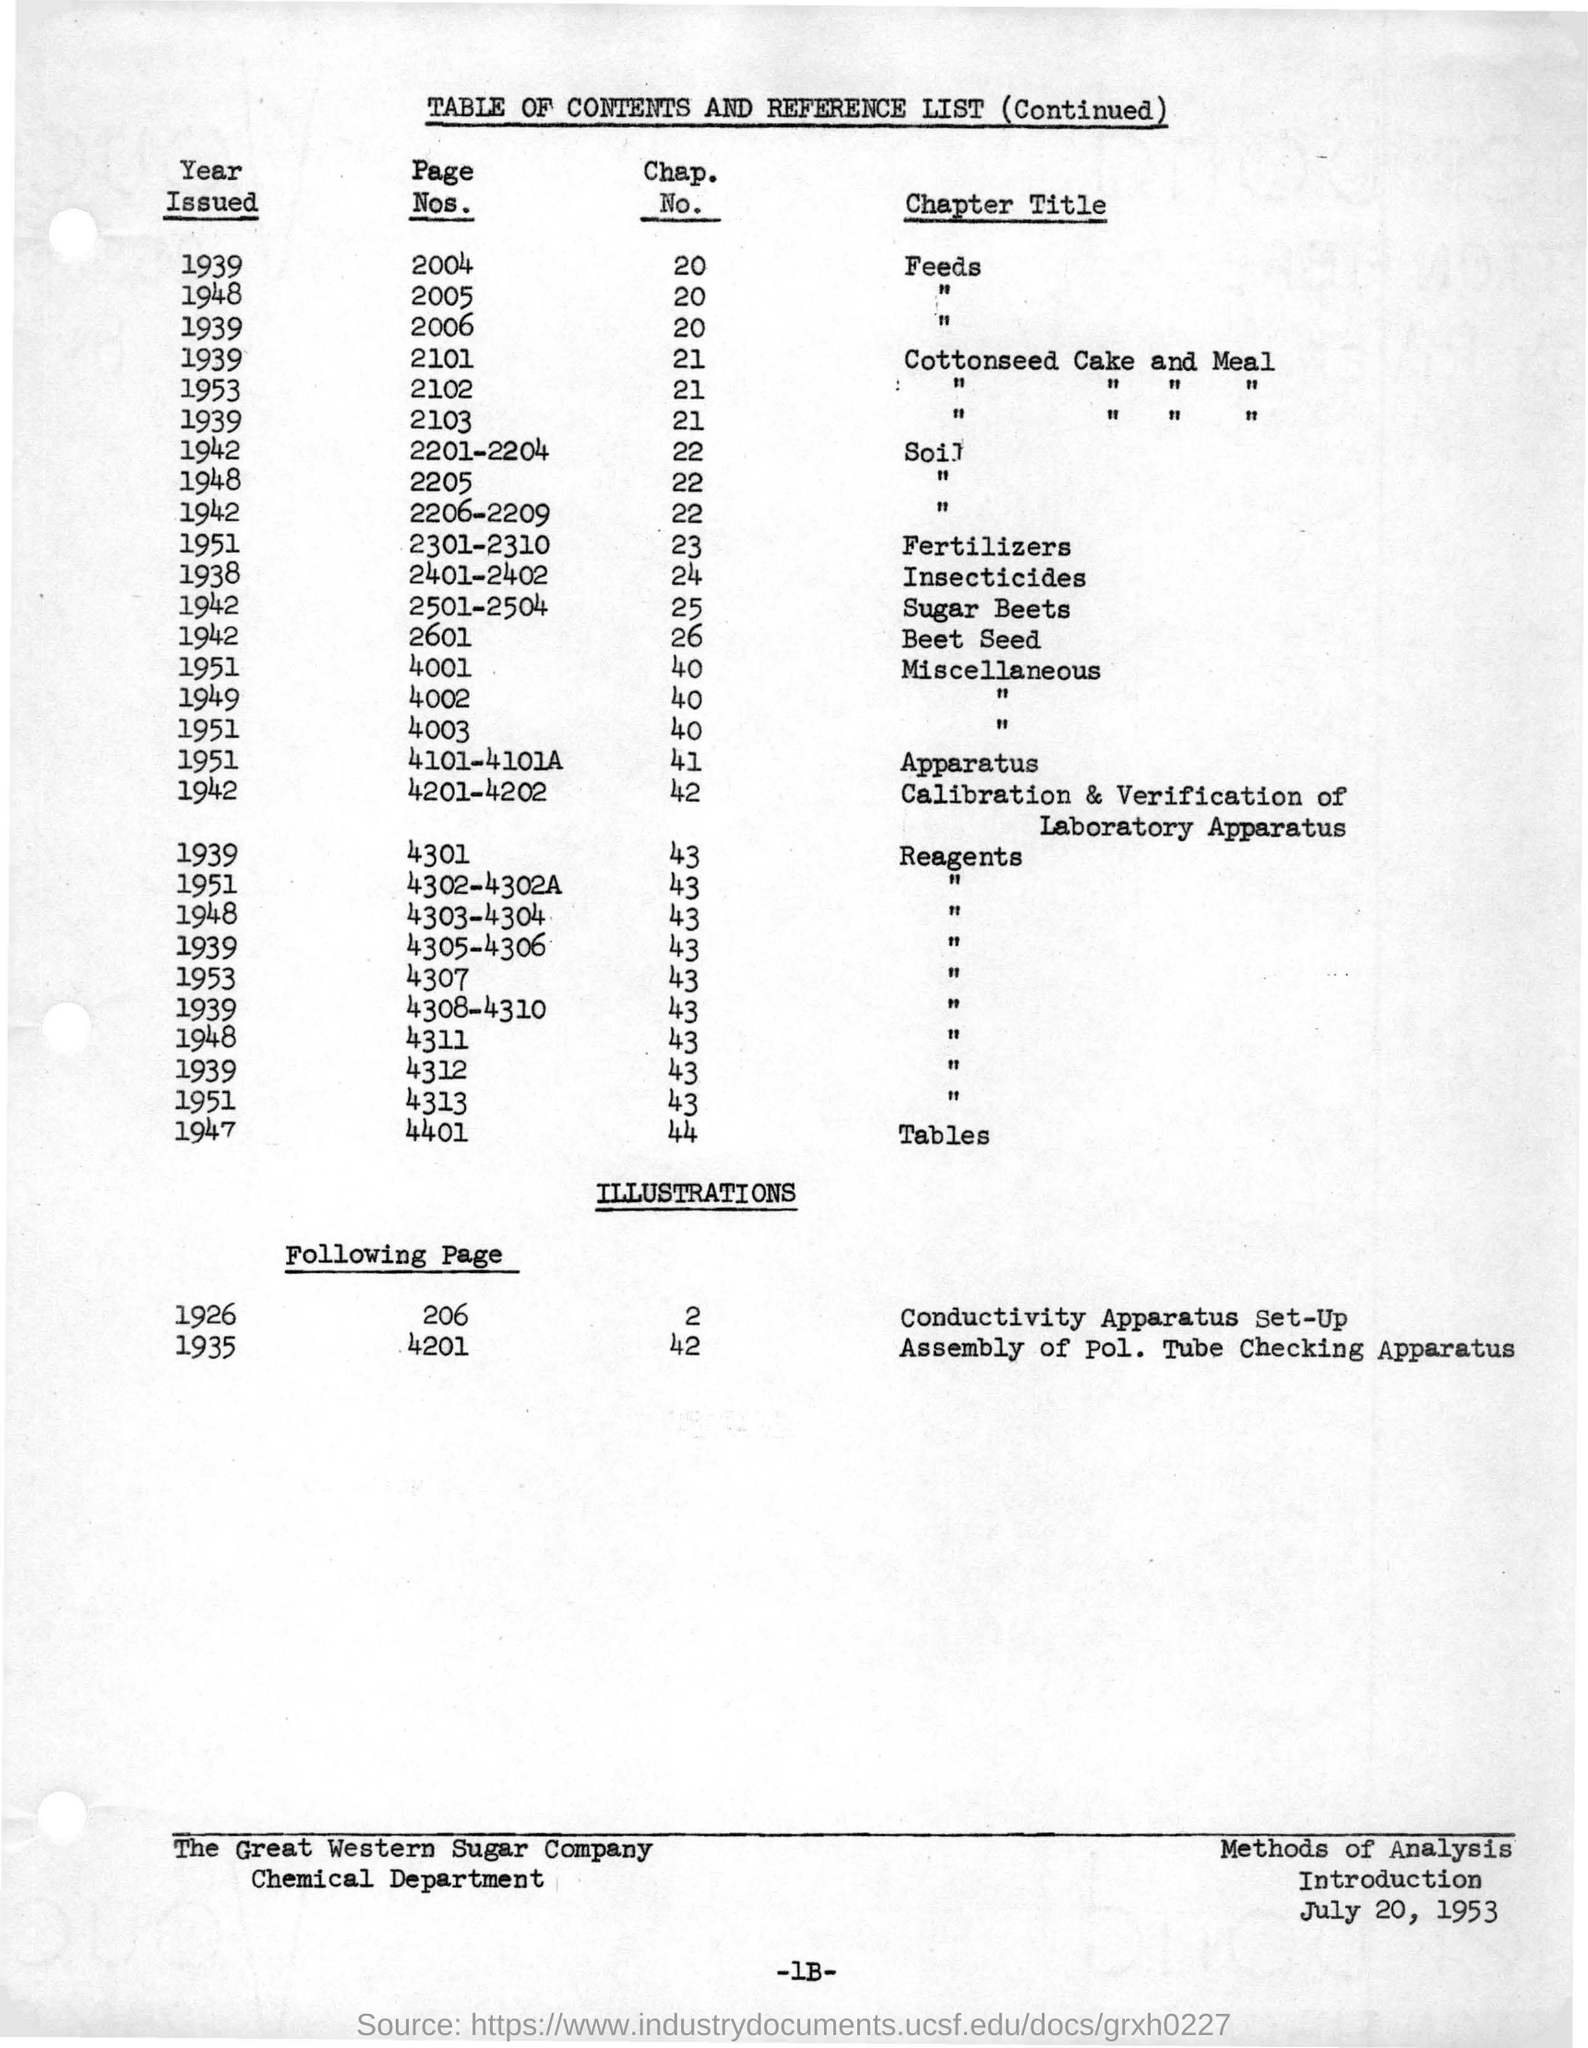Outline some significant characteristics in this image. In 1939, Feeds was issued. The table heading is titled 'TABLE OF CONTENTS AND REFERENCE LIST (Continued).' 